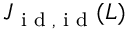Convert formula to latex. <formula><loc_0><loc_0><loc_500><loc_500>J _ { i d , i d } ( L )</formula> 